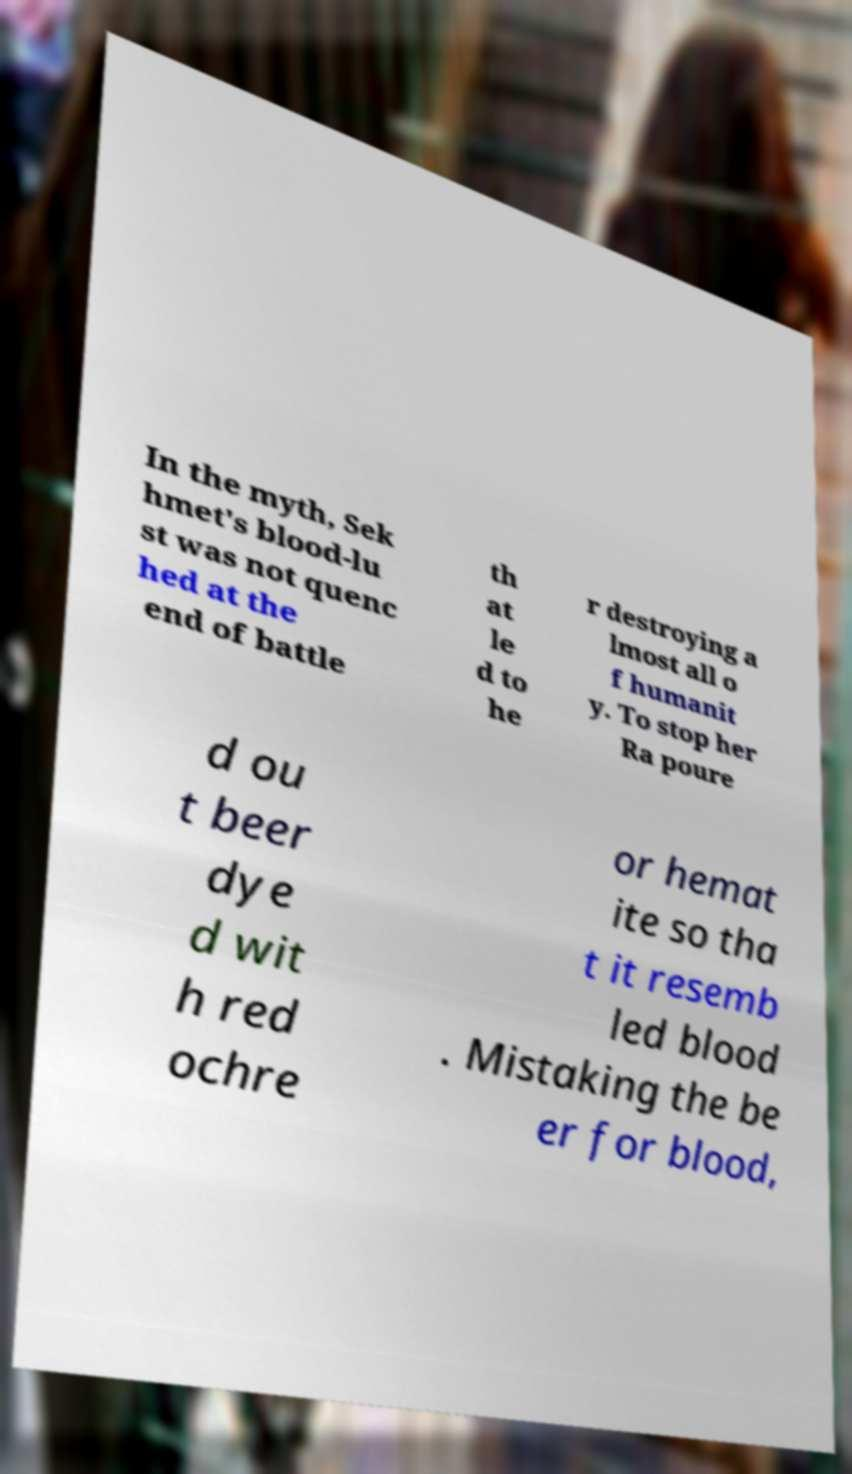Could you assist in decoding the text presented in this image and type it out clearly? In the myth, Sek hmet's blood-lu st was not quenc hed at the end of battle th at le d to he r destroying a lmost all o f humanit y. To stop her Ra poure d ou t beer dye d wit h red ochre or hemat ite so tha t it resemb led blood . Mistaking the be er for blood, 